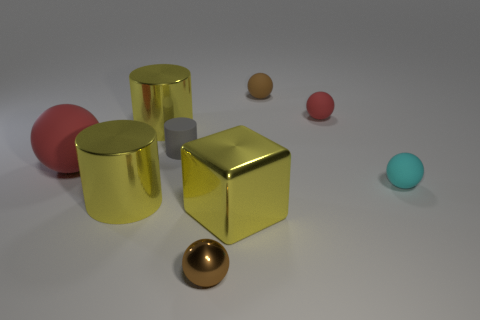What number of other things are there of the same size as the cyan ball?
Provide a succinct answer. 4. Are there the same number of small rubber cylinders to the right of the tiny cyan ball and small gray objects?
Provide a short and direct response. No. There is a large metal cylinder in front of the gray matte cylinder; is its color the same as the big cylinder behind the tiny cyan rubber sphere?
Give a very brief answer. Yes. What is the yellow thing that is both left of the tiny matte cylinder and in front of the cyan thing made of?
Your response must be concise. Metal. What color is the tiny matte cylinder?
Provide a succinct answer. Gray. How many other objects are the same shape as the brown matte thing?
Make the answer very short. 4. Is the number of brown things in front of the big red object the same as the number of small cyan matte spheres right of the small brown matte ball?
Provide a short and direct response. Yes. What is the tiny cyan thing made of?
Provide a succinct answer. Rubber. There is a brown ball behind the tiny red matte object; what is its material?
Keep it short and to the point. Rubber. Is there any other thing that is made of the same material as the small red ball?
Offer a terse response. Yes. 